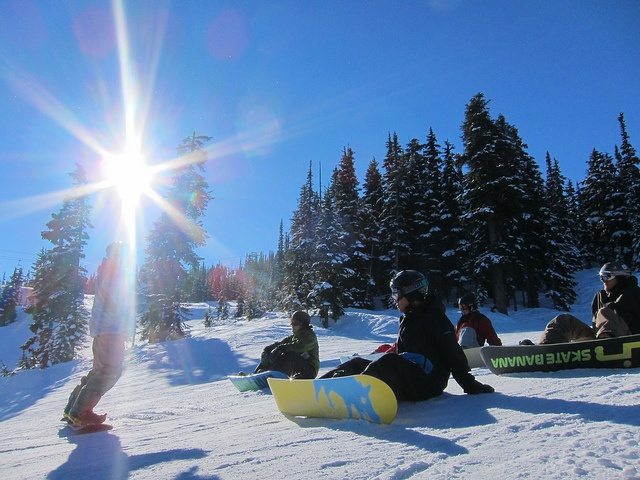Describe the objects in this image and their specific colors. I can see people in gray, black, navy, and maroon tones, people in gray, darkgray, and lavender tones, snowboard in gray and olive tones, snowboard in gray, black, teal, and darkgreen tones, and people in gray, black, and darkgray tones in this image. 